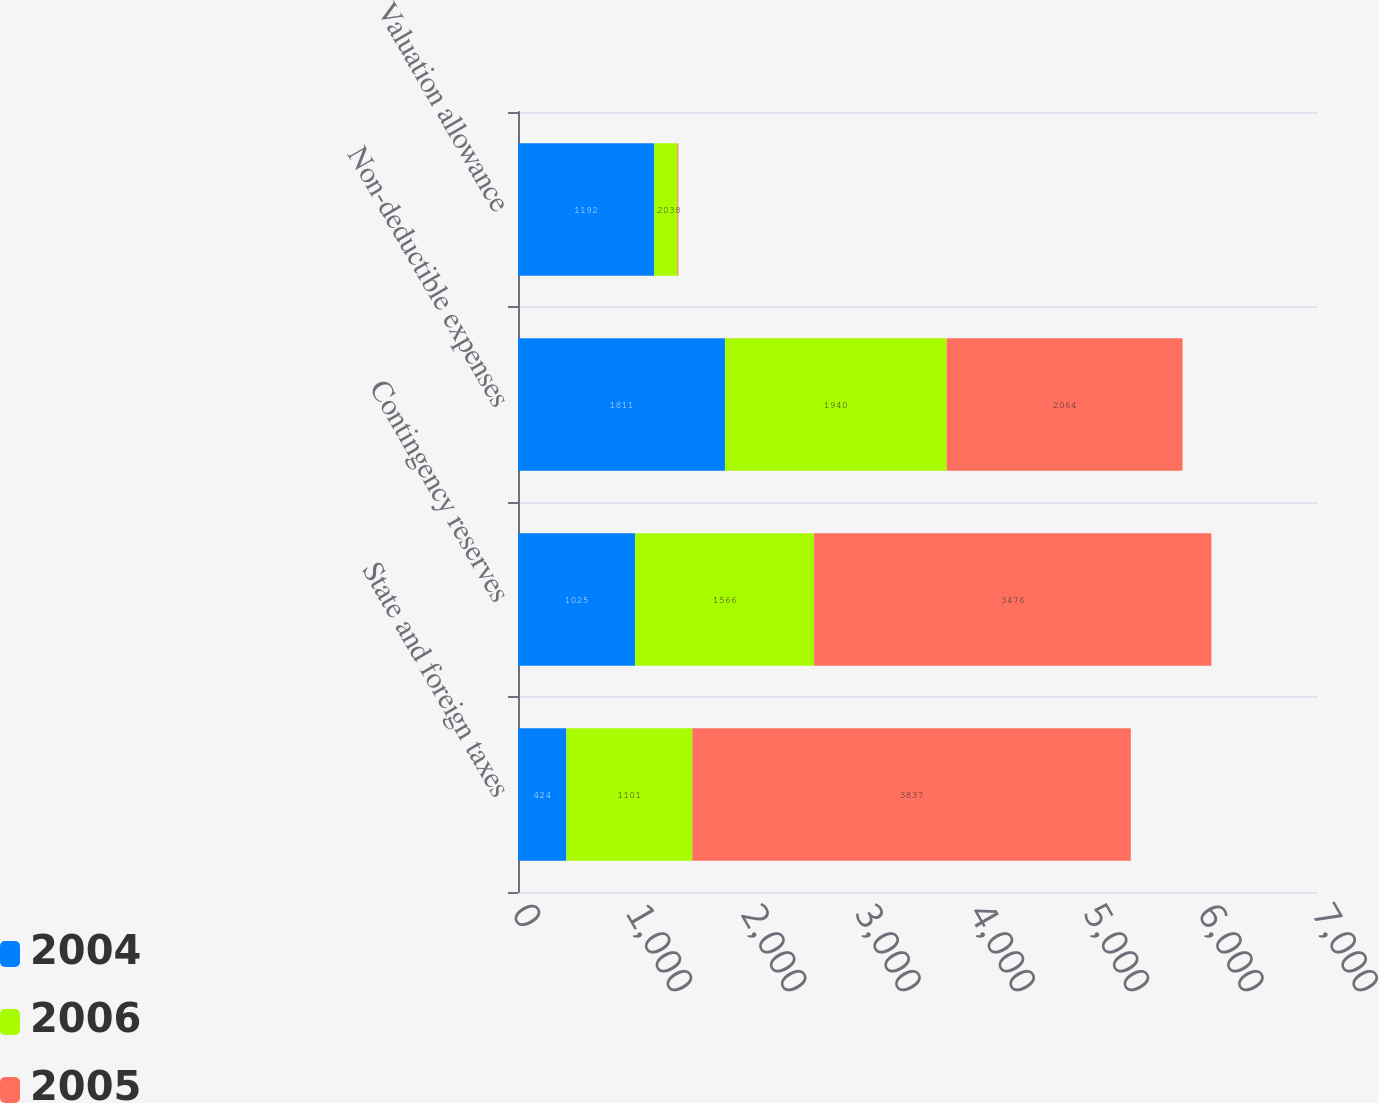Convert chart. <chart><loc_0><loc_0><loc_500><loc_500><stacked_bar_chart><ecel><fcel>State and foreign taxes<fcel>Contingency reserves<fcel>Non-deductible expenses<fcel>Valuation allowance<nl><fcel>2004<fcel>424<fcel>1025<fcel>1811<fcel>1192<nl><fcel>2006<fcel>1101<fcel>1566<fcel>1940<fcel>203<nl><fcel>2005<fcel>3837<fcel>3476<fcel>2064<fcel>8<nl></chart> 